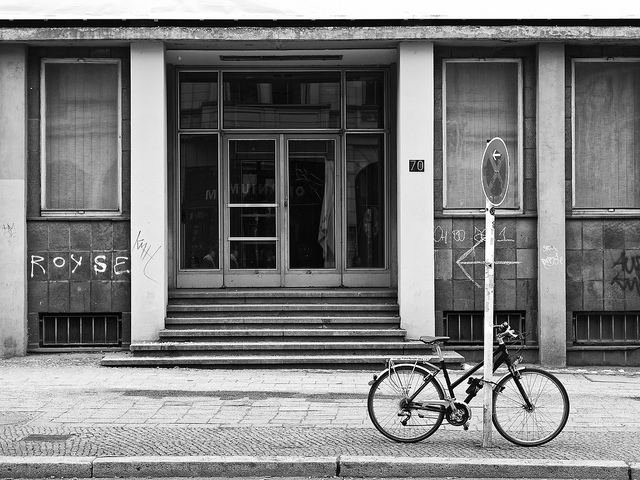Please identify all text content in this image. 80 ROYSE MU O 04 KMH KM AU 7 0 M 1 